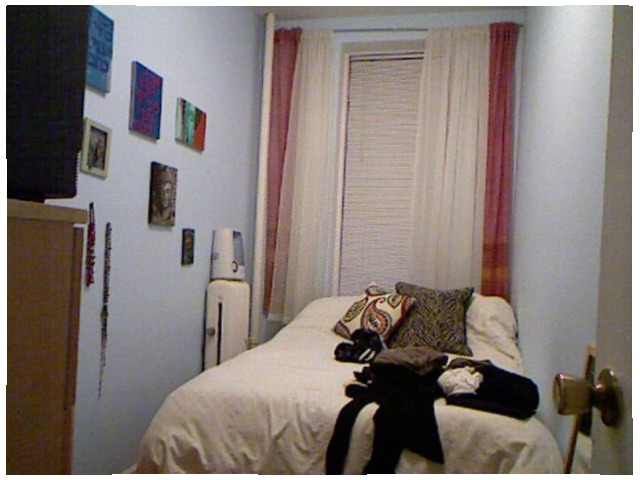<image>
Is there a dress on the bed? Yes. Looking at the image, I can see the dress is positioned on top of the bed, with the bed providing support. Is the dress on the bed? Yes. Looking at the image, I can see the dress is positioned on top of the bed, with the bed providing support. Where is the pillow in relation to the bed? Is it on the bed? Yes. Looking at the image, I can see the pillow is positioned on top of the bed, with the bed providing support. Is the dresser behind the bed? No. The dresser is not behind the bed. From this viewpoint, the dresser appears to be positioned elsewhere in the scene. Is the painting behind the door latch? No. The painting is not behind the door latch. From this viewpoint, the painting appears to be positioned elsewhere in the scene. Is the curtain to the right of the photo frame? Yes. From this viewpoint, the curtain is positioned to the right side relative to the photo frame. 